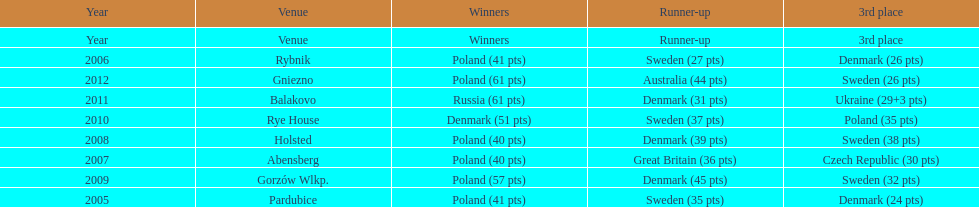What was the variation in the final score between russia and denmark in 2011? 30. 